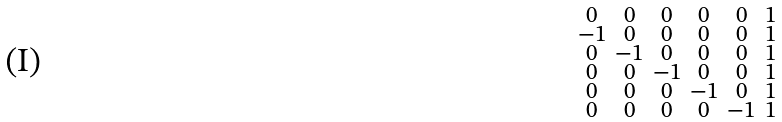<formula> <loc_0><loc_0><loc_500><loc_500>\begin{smallmatrix} 0 & 0 & 0 & 0 & 0 & 1 \\ - 1 & 0 & 0 & 0 & 0 & 1 \\ 0 & - 1 & 0 & 0 & 0 & 1 \\ 0 & 0 & - 1 & 0 & 0 & 1 \\ 0 & 0 & 0 & - 1 & 0 & 1 \\ 0 & 0 & 0 & 0 & - 1 & 1 \end{smallmatrix}</formula> 